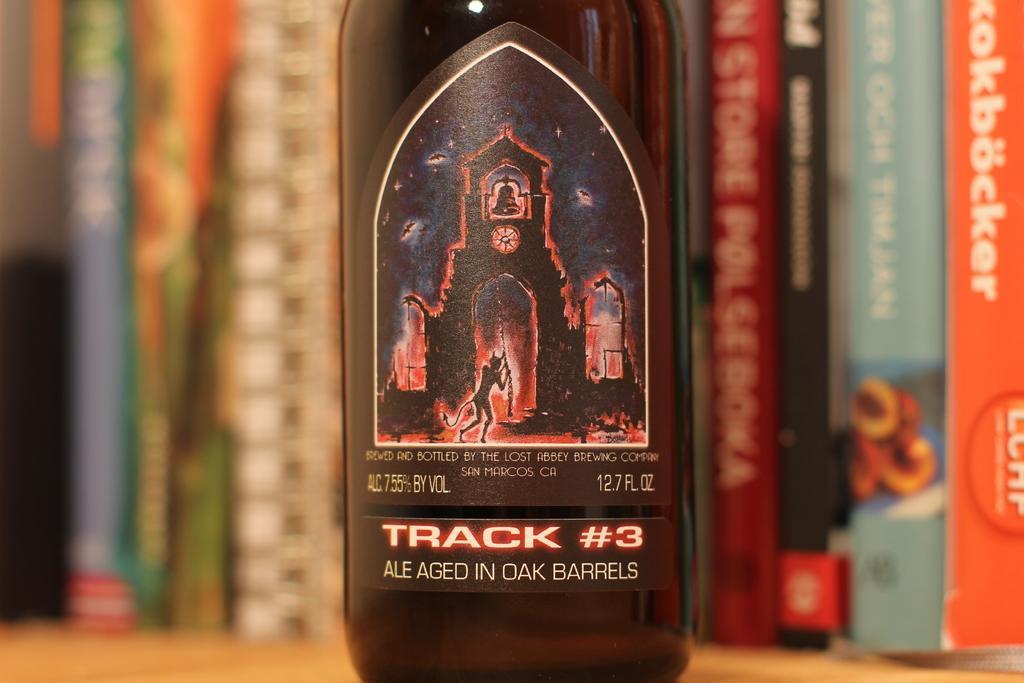In one or two sentences, can you explain what this image depicts? In this picture we can observe bottle placed on the brown color table. There is a red and black color sticker on the bottle. In the background we can observe some books. 